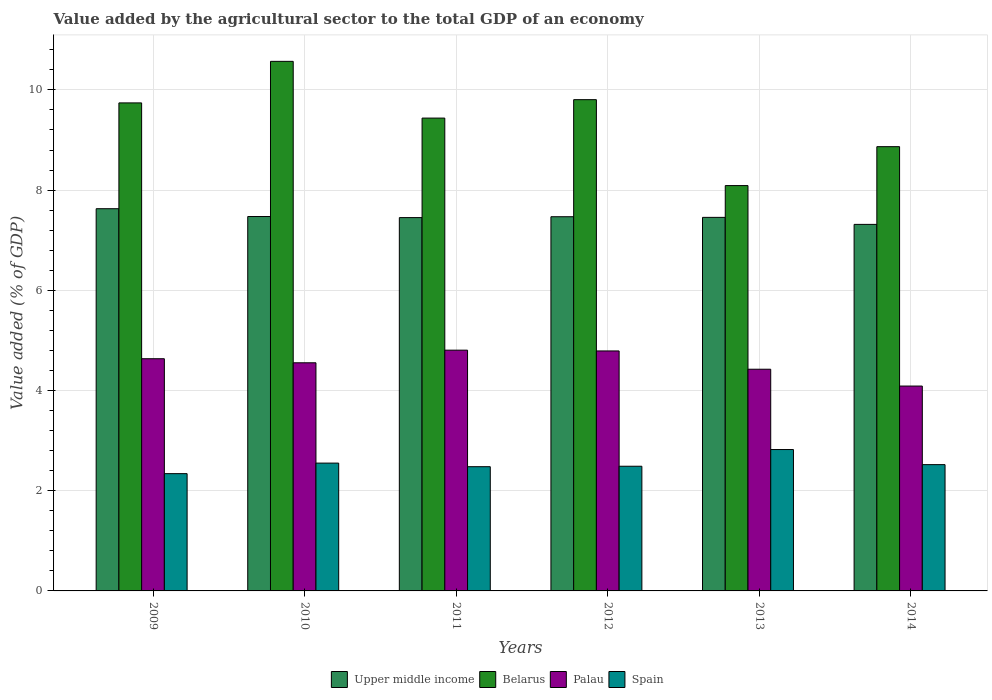How many different coloured bars are there?
Provide a succinct answer. 4. How many groups of bars are there?
Offer a terse response. 6. Are the number of bars per tick equal to the number of legend labels?
Provide a succinct answer. Yes. How many bars are there on the 2nd tick from the right?
Give a very brief answer. 4. What is the label of the 1st group of bars from the left?
Your response must be concise. 2009. In how many cases, is the number of bars for a given year not equal to the number of legend labels?
Provide a succinct answer. 0. What is the value added by the agricultural sector to the total GDP in Palau in 2014?
Offer a very short reply. 4.09. Across all years, what is the maximum value added by the agricultural sector to the total GDP in Spain?
Keep it short and to the point. 2.82. Across all years, what is the minimum value added by the agricultural sector to the total GDP in Upper middle income?
Give a very brief answer. 7.32. What is the total value added by the agricultural sector to the total GDP in Belarus in the graph?
Your response must be concise. 56.51. What is the difference between the value added by the agricultural sector to the total GDP in Spain in 2013 and that in 2014?
Offer a terse response. 0.3. What is the difference between the value added by the agricultural sector to the total GDP in Belarus in 2014 and the value added by the agricultural sector to the total GDP in Palau in 2009?
Your answer should be compact. 4.23. What is the average value added by the agricultural sector to the total GDP in Upper middle income per year?
Your answer should be compact. 7.47. In the year 2012, what is the difference between the value added by the agricultural sector to the total GDP in Spain and value added by the agricultural sector to the total GDP in Palau?
Offer a terse response. -2.3. In how many years, is the value added by the agricultural sector to the total GDP in Upper middle income greater than 8.8 %?
Provide a short and direct response. 0. What is the ratio of the value added by the agricultural sector to the total GDP in Palau in 2010 to that in 2011?
Offer a terse response. 0.95. Is the value added by the agricultural sector to the total GDP in Palau in 2010 less than that in 2014?
Offer a very short reply. No. What is the difference between the highest and the second highest value added by the agricultural sector to the total GDP in Upper middle income?
Keep it short and to the point. 0.16. What is the difference between the highest and the lowest value added by the agricultural sector to the total GDP in Palau?
Your answer should be compact. 0.72. Is it the case that in every year, the sum of the value added by the agricultural sector to the total GDP in Upper middle income and value added by the agricultural sector to the total GDP in Belarus is greater than the sum of value added by the agricultural sector to the total GDP in Palau and value added by the agricultural sector to the total GDP in Spain?
Your response must be concise. Yes. What does the 1st bar from the left in 2010 represents?
Your answer should be very brief. Upper middle income. What does the 4th bar from the right in 2013 represents?
Provide a succinct answer. Upper middle income. How many bars are there?
Keep it short and to the point. 24. Are all the bars in the graph horizontal?
Offer a terse response. No. How many years are there in the graph?
Offer a terse response. 6. What is the difference between two consecutive major ticks on the Y-axis?
Your answer should be very brief. 2. Does the graph contain any zero values?
Your answer should be compact. No. Does the graph contain grids?
Your response must be concise. Yes. How many legend labels are there?
Offer a very short reply. 4. How are the legend labels stacked?
Offer a terse response. Horizontal. What is the title of the graph?
Give a very brief answer. Value added by the agricultural sector to the total GDP of an economy. What is the label or title of the X-axis?
Your answer should be very brief. Years. What is the label or title of the Y-axis?
Offer a very short reply. Value added (% of GDP). What is the Value added (% of GDP) in Upper middle income in 2009?
Your response must be concise. 7.63. What is the Value added (% of GDP) of Belarus in 2009?
Ensure brevity in your answer.  9.74. What is the Value added (% of GDP) of Palau in 2009?
Provide a succinct answer. 4.63. What is the Value added (% of GDP) in Spain in 2009?
Your response must be concise. 2.34. What is the Value added (% of GDP) of Upper middle income in 2010?
Your answer should be compact. 7.47. What is the Value added (% of GDP) in Belarus in 2010?
Your response must be concise. 10.57. What is the Value added (% of GDP) in Palau in 2010?
Make the answer very short. 4.55. What is the Value added (% of GDP) in Spain in 2010?
Offer a very short reply. 2.55. What is the Value added (% of GDP) in Upper middle income in 2011?
Your answer should be compact. 7.45. What is the Value added (% of GDP) in Belarus in 2011?
Offer a very short reply. 9.44. What is the Value added (% of GDP) of Palau in 2011?
Offer a very short reply. 4.81. What is the Value added (% of GDP) in Spain in 2011?
Ensure brevity in your answer.  2.48. What is the Value added (% of GDP) in Upper middle income in 2012?
Offer a terse response. 7.47. What is the Value added (% of GDP) in Belarus in 2012?
Offer a very short reply. 9.8. What is the Value added (% of GDP) in Palau in 2012?
Your answer should be compact. 4.79. What is the Value added (% of GDP) in Spain in 2012?
Your answer should be very brief. 2.49. What is the Value added (% of GDP) in Upper middle income in 2013?
Your answer should be very brief. 7.46. What is the Value added (% of GDP) of Belarus in 2013?
Ensure brevity in your answer.  8.09. What is the Value added (% of GDP) of Palau in 2013?
Make the answer very short. 4.42. What is the Value added (% of GDP) of Spain in 2013?
Your answer should be compact. 2.82. What is the Value added (% of GDP) of Upper middle income in 2014?
Keep it short and to the point. 7.32. What is the Value added (% of GDP) in Belarus in 2014?
Give a very brief answer. 8.87. What is the Value added (% of GDP) of Palau in 2014?
Ensure brevity in your answer.  4.09. What is the Value added (% of GDP) of Spain in 2014?
Your response must be concise. 2.52. Across all years, what is the maximum Value added (% of GDP) of Upper middle income?
Give a very brief answer. 7.63. Across all years, what is the maximum Value added (% of GDP) in Belarus?
Your response must be concise. 10.57. Across all years, what is the maximum Value added (% of GDP) in Palau?
Your response must be concise. 4.81. Across all years, what is the maximum Value added (% of GDP) of Spain?
Your answer should be very brief. 2.82. Across all years, what is the minimum Value added (% of GDP) in Upper middle income?
Provide a short and direct response. 7.32. Across all years, what is the minimum Value added (% of GDP) in Belarus?
Provide a short and direct response. 8.09. Across all years, what is the minimum Value added (% of GDP) of Palau?
Offer a terse response. 4.09. Across all years, what is the minimum Value added (% of GDP) of Spain?
Offer a terse response. 2.34. What is the total Value added (% of GDP) in Upper middle income in the graph?
Offer a very short reply. 44.79. What is the total Value added (% of GDP) of Belarus in the graph?
Provide a succinct answer. 56.51. What is the total Value added (% of GDP) of Palau in the graph?
Your response must be concise. 27.3. What is the total Value added (% of GDP) of Spain in the graph?
Provide a succinct answer. 15.2. What is the difference between the Value added (% of GDP) in Upper middle income in 2009 and that in 2010?
Keep it short and to the point. 0.16. What is the difference between the Value added (% of GDP) of Belarus in 2009 and that in 2010?
Offer a terse response. -0.83. What is the difference between the Value added (% of GDP) of Palau in 2009 and that in 2010?
Your response must be concise. 0.08. What is the difference between the Value added (% of GDP) of Spain in 2009 and that in 2010?
Provide a short and direct response. -0.21. What is the difference between the Value added (% of GDP) of Upper middle income in 2009 and that in 2011?
Give a very brief answer. 0.18. What is the difference between the Value added (% of GDP) in Belarus in 2009 and that in 2011?
Your answer should be very brief. 0.3. What is the difference between the Value added (% of GDP) of Palau in 2009 and that in 2011?
Your answer should be very brief. -0.17. What is the difference between the Value added (% of GDP) in Spain in 2009 and that in 2011?
Provide a succinct answer. -0.14. What is the difference between the Value added (% of GDP) in Upper middle income in 2009 and that in 2012?
Provide a short and direct response. 0.16. What is the difference between the Value added (% of GDP) of Belarus in 2009 and that in 2012?
Ensure brevity in your answer.  -0.06. What is the difference between the Value added (% of GDP) of Palau in 2009 and that in 2012?
Make the answer very short. -0.16. What is the difference between the Value added (% of GDP) of Spain in 2009 and that in 2012?
Make the answer very short. -0.15. What is the difference between the Value added (% of GDP) in Upper middle income in 2009 and that in 2013?
Offer a very short reply. 0.17. What is the difference between the Value added (% of GDP) in Belarus in 2009 and that in 2013?
Your answer should be compact. 1.65. What is the difference between the Value added (% of GDP) in Palau in 2009 and that in 2013?
Ensure brevity in your answer.  0.21. What is the difference between the Value added (% of GDP) of Spain in 2009 and that in 2013?
Ensure brevity in your answer.  -0.48. What is the difference between the Value added (% of GDP) in Upper middle income in 2009 and that in 2014?
Ensure brevity in your answer.  0.31. What is the difference between the Value added (% of GDP) in Belarus in 2009 and that in 2014?
Keep it short and to the point. 0.87. What is the difference between the Value added (% of GDP) in Palau in 2009 and that in 2014?
Give a very brief answer. 0.55. What is the difference between the Value added (% of GDP) of Spain in 2009 and that in 2014?
Your answer should be very brief. -0.18. What is the difference between the Value added (% of GDP) in Upper middle income in 2010 and that in 2011?
Your answer should be very brief. 0.02. What is the difference between the Value added (% of GDP) in Belarus in 2010 and that in 2011?
Keep it short and to the point. 1.13. What is the difference between the Value added (% of GDP) of Palau in 2010 and that in 2011?
Make the answer very short. -0.25. What is the difference between the Value added (% of GDP) in Spain in 2010 and that in 2011?
Keep it short and to the point. 0.07. What is the difference between the Value added (% of GDP) in Upper middle income in 2010 and that in 2012?
Make the answer very short. 0. What is the difference between the Value added (% of GDP) in Belarus in 2010 and that in 2012?
Ensure brevity in your answer.  0.76. What is the difference between the Value added (% of GDP) of Palau in 2010 and that in 2012?
Your answer should be compact. -0.24. What is the difference between the Value added (% of GDP) of Spain in 2010 and that in 2012?
Offer a terse response. 0.06. What is the difference between the Value added (% of GDP) of Upper middle income in 2010 and that in 2013?
Your response must be concise. 0.02. What is the difference between the Value added (% of GDP) of Belarus in 2010 and that in 2013?
Your answer should be compact. 2.48. What is the difference between the Value added (% of GDP) in Palau in 2010 and that in 2013?
Make the answer very short. 0.13. What is the difference between the Value added (% of GDP) in Spain in 2010 and that in 2013?
Offer a terse response. -0.27. What is the difference between the Value added (% of GDP) of Upper middle income in 2010 and that in 2014?
Your answer should be compact. 0.16. What is the difference between the Value added (% of GDP) in Belarus in 2010 and that in 2014?
Provide a short and direct response. 1.7. What is the difference between the Value added (% of GDP) of Palau in 2010 and that in 2014?
Your answer should be very brief. 0.46. What is the difference between the Value added (% of GDP) in Spain in 2010 and that in 2014?
Keep it short and to the point. 0.03. What is the difference between the Value added (% of GDP) of Upper middle income in 2011 and that in 2012?
Ensure brevity in your answer.  -0.02. What is the difference between the Value added (% of GDP) in Belarus in 2011 and that in 2012?
Offer a terse response. -0.37. What is the difference between the Value added (% of GDP) of Palau in 2011 and that in 2012?
Your response must be concise. 0.02. What is the difference between the Value added (% of GDP) in Spain in 2011 and that in 2012?
Ensure brevity in your answer.  -0.01. What is the difference between the Value added (% of GDP) in Upper middle income in 2011 and that in 2013?
Your answer should be compact. -0. What is the difference between the Value added (% of GDP) of Belarus in 2011 and that in 2013?
Ensure brevity in your answer.  1.35. What is the difference between the Value added (% of GDP) in Palau in 2011 and that in 2013?
Make the answer very short. 0.38. What is the difference between the Value added (% of GDP) of Spain in 2011 and that in 2013?
Make the answer very short. -0.34. What is the difference between the Value added (% of GDP) of Upper middle income in 2011 and that in 2014?
Offer a very short reply. 0.14. What is the difference between the Value added (% of GDP) of Belarus in 2011 and that in 2014?
Your answer should be compact. 0.57. What is the difference between the Value added (% of GDP) in Palau in 2011 and that in 2014?
Provide a succinct answer. 0.72. What is the difference between the Value added (% of GDP) in Spain in 2011 and that in 2014?
Provide a short and direct response. -0.04. What is the difference between the Value added (% of GDP) in Upper middle income in 2012 and that in 2013?
Provide a succinct answer. 0.01. What is the difference between the Value added (% of GDP) in Belarus in 2012 and that in 2013?
Your answer should be compact. 1.72. What is the difference between the Value added (% of GDP) in Palau in 2012 and that in 2013?
Provide a succinct answer. 0.36. What is the difference between the Value added (% of GDP) in Upper middle income in 2012 and that in 2014?
Your response must be concise. 0.15. What is the difference between the Value added (% of GDP) in Belarus in 2012 and that in 2014?
Ensure brevity in your answer.  0.94. What is the difference between the Value added (% of GDP) in Palau in 2012 and that in 2014?
Provide a succinct answer. 0.7. What is the difference between the Value added (% of GDP) of Spain in 2012 and that in 2014?
Keep it short and to the point. -0.03. What is the difference between the Value added (% of GDP) in Upper middle income in 2013 and that in 2014?
Your response must be concise. 0.14. What is the difference between the Value added (% of GDP) of Belarus in 2013 and that in 2014?
Your answer should be very brief. -0.78. What is the difference between the Value added (% of GDP) in Palau in 2013 and that in 2014?
Your answer should be very brief. 0.34. What is the difference between the Value added (% of GDP) of Spain in 2013 and that in 2014?
Ensure brevity in your answer.  0.3. What is the difference between the Value added (% of GDP) of Upper middle income in 2009 and the Value added (% of GDP) of Belarus in 2010?
Provide a succinct answer. -2.94. What is the difference between the Value added (% of GDP) of Upper middle income in 2009 and the Value added (% of GDP) of Palau in 2010?
Provide a succinct answer. 3.08. What is the difference between the Value added (% of GDP) of Upper middle income in 2009 and the Value added (% of GDP) of Spain in 2010?
Your answer should be very brief. 5.08. What is the difference between the Value added (% of GDP) in Belarus in 2009 and the Value added (% of GDP) in Palau in 2010?
Keep it short and to the point. 5.19. What is the difference between the Value added (% of GDP) of Belarus in 2009 and the Value added (% of GDP) of Spain in 2010?
Make the answer very short. 7.19. What is the difference between the Value added (% of GDP) in Palau in 2009 and the Value added (% of GDP) in Spain in 2010?
Offer a terse response. 2.08. What is the difference between the Value added (% of GDP) of Upper middle income in 2009 and the Value added (% of GDP) of Belarus in 2011?
Ensure brevity in your answer.  -1.81. What is the difference between the Value added (% of GDP) in Upper middle income in 2009 and the Value added (% of GDP) in Palau in 2011?
Your answer should be compact. 2.82. What is the difference between the Value added (% of GDP) in Upper middle income in 2009 and the Value added (% of GDP) in Spain in 2011?
Provide a short and direct response. 5.15. What is the difference between the Value added (% of GDP) of Belarus in 2009 and the Value added (% of GDP) of Palau in 2011?
Your response must be concise. 4.93. What is the difference between the Value added (% of GDP) of Belarus in 2009 and the Value added (% of GDP) of Spain in 2011?
Make the answer very short. 7.26. What is the difference between the Value added (% of GDP) of Palau in 2009 and the Value added (% of GDP) of Spain in 2011?
Make the answer very short. 2.15. What is the difference between the Value added (% of GDP) in Upper middle income in 2009 and the Value added (% of GDP) in Belarus in 2012?
Make the answer very short. -2.18. What is the difference between the Value added (% of GDP) in Upper middle income in 2009 and the Value added (% of GDP) in Palau in 2012?
Your response must be concise. 2.84. What is the difference between the Value added (% of GDP) of Upper middle income in 2009 and the Value added (% of GDP) of Spain in 2012?
Your answer should be compact. 5.14. What is the difference between the Value added (% of GDP) in Belarus in 2009 and the Value added (% of GDP) in Palau in 2012?
Offer a very short reply. 4.95. What is the difference between the Value added (% of GDP) in Belarus in 2009 and the Value added (% of GDP) in Spain in 2012?
Ensure brevity in your answer.  7.25. What is the difference between the Value added (% of GDP) of Palau in 2009 and the Value added (% of GDP) of Spain in 2012?
Your response must be concise. 2.15. What is the difference between the Value added (% of GDP) of Upper middle income in 2009 and the Value added (% of GDP) of Belarus in 2013?
Offer a very short reply. -0.46. What is the difference between the Value added (% of GDP) in Upper middle income in 2009 and the Value added (% of GDP) in Palau in 2013?
Your response must be concise. 3.2. What is the difference between the Value added (% of GDP) in Upper middle income in 2009 and the Value added (% of GDP) in Spain in 2013?
Provide a succinct answer. 4.81. What is the difference between the Value added (% of GDP) in Belarus in 2009 and the Value added (% of GDP) in Palau in 2013?
Keep it short and to the point. 5.32. What is the difference between the Value added (% of GDP) of Belarus in 2009 and the Value added (% of GDP) of Spain in 2013?
Your response must be concise. 6.92. What is the difference between the Value added (% of GDP) in Palau in 2009 and the Value added (% of GDP) in Spain in 2013?
Keep it short and to the point. 1.81. What is the difference between the Value added (% of GDP) of Upper middle income in 2009 and the Value added (% of GDP) of Belarus in 2014?
Make the answer very short. -1.24. What is the difference between the Value added (% of GDP) of Upper middle income in 2009 and the Value added (% of GDP) of Palau in 2014?
Your response must be concise. 3.54. What is the difference between the Value added (% of GDP) in Upper middle income in 2009 and the Value added (% of GDP) in Spain in 2014?
Ensure brevity in your answer.  5.11. What is the difference between the Value added (% of GDP) of Belarus in 2009 and the Value added (% of GDP) of Palau in 2014?
Offer a terse response. 5.65. What is the difference between the Value added (% of GDP) of Belarus in 2009 and the Value added (% of GDP) of Spain in 2014?
Your answer should be very brief. 7.22. What is the difference between the Value added (% of GDP) of Palau in 2009 and the Value added (% of GDP) of Spain in 2014?
Offer a terse response. 2.11. What is the difference between the Value added (% of GDP) of Upper middle income in 2010 and the Value added (% of GDP) of Belarus in 2011?
Give a very brief answer. -1.96. What is the difference between the Value added (% of GDP) in Upper middle income in 2010 and the Value added (% of GDP) in Palau in 2011?
Provide a succinct answer. 2.67. What is the difference between the Value added (% of GDP) in Upper middle income in 2010 and the Value added (% of GDP) in Spain in 2011?
Make the answer very short. 4.99. What is the difference between the Value added (% of GDP) in Belarus in 2010 and the Value added (% of GDP) in Palau in 2011?
Your response must be concise. 5.76. What is the difference between the Value added (% of GDP) in Belarus in 2010 and the Value added (% of GDP) in Spain in 2011?
Your answer should be very brief. 8.09. What is the difference between the Value added (% of GDP) in Palau in 2010 and the Value added (% of GDP) in Spain in 2011?
Offer a terse response. 2.07. What is the difference between the Value added (% of GDP) in Upper middle income in 2010 and the Value added (% of GDP) in Belarus in 2012?
Ensure brevity in your answer.  -2.33. What is the difference between the Value added (% of GDP) of Upper middle income in 2010 and the Value added (% of GDP) of Palau in 2012?
Your answer should be very brief. 2.68. What is the difference between the Value added (% of GDP) of Upper middle income in 2010 and the Value added (% of GDP) of Spain in 2012?
Offer a terse response. 4.98. What is the difference between the Value added (% of GDP) of Belarus in 2010 and the Value added (% of GDP) of Palau in 2012?
Your answer should be compact. 5.78. What is the difference between the Value added (% of GDP) in Belarus in 2010 and the Value added (% of GDP) in Spain in 2012?
Offer a terse response. 8.08. What is the difference between the Value added (% of GDP) of Palau in 2010 and the Value added (% of GDP) of Spain in 2012?
Offer a very short reply. 2.06. What is the difference between the Value added (% of GDP) of Upper middle income in 2010 and the Value added (% of GDP) of Belarus in 2013?
Offer a very short reply. -0.62. What is the difference between the Value added (% of GDP) of Upper middle income in 2010 and the Value added (% of GDP) of Palau in 2013?
Give a very brief answer. 3.05. What is the difference between the Value added (% of GDP) of Upper middle income in 2010 and the Value added (% of GDP) of Spain in 2013?
Offer a terse response. 4.65. What is the difference between the Value added (% of GDP) of Belarus in 2010 and the Value added (% of GDP) of Palau in 2013?
Provide a succinct answer. 6.14. What is the difference between the Value added (% of GDP) in Belarus in 2010 and the Value added (% of GDP) in Spain in 2013?
Keep it short and to the point. 7.75. What is the difference between the Value added (% of GDP) in Palau in 2010 and the Value added (% of GDP) in Spain in 2013?
Offer a terse response. 1.73. What is the difference between the Value added (% of GDP) in Upper middle income in 2010 and the Value added (% of GDP) in Belarus in 2014?
Your answer should be very brief. -1.39. What is the difference between the Value added (% of GDP) of Upper middle income in 2010 and the Value added (% of GDP) of Palau in 2014?
Provide a short and direct response. 3.38. What is the difference between the Value added (% of GDP) of Upper middle income in 2010 and the Value added (% of GDP) of Spain in 2014?
Your answer should be compact. 4.95. What is the difference between the Value added (% of GDP) in Belarus in 2010 and the Value added (% of GDP) in Palau in 2014?
Your answer should be very brief. 6.48. What is the difference between the Value added (% of GDP) of Belarus in 2010 and the Value added (% of GDP) of Spain in 2014?
Your response must be concise. 8.05. What is the difference between the Value added (% of GDP) in Palau in 2010 and the Value added (% of GDP) in Spain in 2014?
Offer a very short reply. 2.03. What is the difference between the Value added (% of GDP) in Upper middle income in 2011 and the Value added (% of GDP) in Belarus in 2012?
Make the answer very short. -2.35. What is the difference between the Value added (% of GDP) of Upper middle income in 2011 and the Value added (% of GDP) of Palau in 2012?
Offer a terse response. 2.66. What is the difference between the Value added (% of GDP) of Upper middle income in 2011 and the Value added (% of GDP) of Spain in 2012?
Provide a succinct answer. 4.96. What is the difference between the Value added (% of GDP) of Belarus in 2011 and the Value added (% of GDP) of Palau in 2012?
Give a very brief answer. 4.65. What is the difference between the Value added (% of GDP) of Belarus in 2011 and the Value added (% of GDP) of Spain in 2012?
Provide a short and direct response. 6.95. What is the difference between the Value added (% of GDP) of Palau in 2011 and the Value added (% of GDP) of Spain in 2012?
Offer a terse response. 2.32. What is the difference between the Value added (% of GDP) in Upper middle income in 2011 and the Value added (% of GDP) in Belarus in 2013?
Your response must be concise. -0.64. What is the difference between the Value added (% of GDP) of Upper middle income in 2011 and the Value added (% of GDP) of Palau in 2013?
Provide a short and direct response. 3.03. What is the difference between the Value added (% of GDP) of Upper middle income in 2011 and the Value added (% of GDP) of Spain in 2013?
Ensure brevity in your answer.  4.63. What is the difference between the Value added (% of GDP) of Belarus in 2011 and the Value added (% of GDP) of Palau in 2013?
Your response must be concise. 5.01. What is the difference between the Value added (% of GDP) of Belarus in 2011 and the Value added (% of GDP) of Spain in 2013?
Provide a succinct answer. 6.62. What is the difference between the Value added (% of GDP) of Palau in 2011 and the Value added (% of GDP) of Spain in 2013?
Ensure brevity in your answer.  1.98. What is the difference between the Value added (% of GDP) of Upper middle income in 2011 and the Value added (% of GDP) of Belarus in 2014?
Your response must be concise. -1.42. What is the difference between the Value added (% of GDP) in Upper middle income in 2011 and the Value added (% of GDP) in Palau in 2014?
Provide a short and direct response. 3.36. What is the difference between the Value added (% of GDP) of Upper middle income in 2011 and the Value added (% of GDP) of Spain in 2014?
Ensure brevity in your answer.  4.93. What is the difference between the Value added (% of GDP) in Belarus in 2011 and the Value added (% of GDP) in Palau in 2014?
Make the answer very short. 5.35. What is the difference between the Value added (% of GDP) in Belarus in 2011 and the Value added (% of GDP) in Spain in 2014?
Ensure brevity in your answer.  6.92. What is the difference between the Value added (% of GDP) of Palau in 2011 and the Value added (% of GDP) of Spain in 2014?
Ensure brevity in your answer.  2.28. What is the difference between the Value added (% of GDP) of Upper middle income in 2012 and the Value added (% of GDP) of Belarus in 2013?
Offer a terse response. -0.62. What is the difference between the Value added (% of GDP) of Upper middle income in 2012 and the Value added (% of GDP) of Palau in 2013?
Give a very brief answer. 3.04. What is the difference between the Value added (% of GDP) in Upper middle income in 2012 and the Value added (% of GDP) in Spain in 2013?
Provide a short and direct response. 4.65. What is the difference between the Value added (% of GDP) of Belarus in 2012 and the Value added (% of GDP) of Palau in 2013?
Provide a succinct answer. 5.38. What is the difference between the Value added (% of GDP) in Belarus in 2012 and the Value added (% of GDP) in Spain in 2013?
Provide a succinct answer. 6.98. What is the difference between the Value added (% of GDP) in Palau in 2012 and the Value added (% of GDP) in Spain in 2013?
Offer a very short reply. 1.97. What is the difference between the Value added (% of GDP) of Upper middle income in 2012 and the Value added (% of GDP) of Belarus in 2014?
Your answer should be compact. -1.4. What is the difference between the Value added (% of GDP) in Upper middle income in 2012 and the Value added (% of GDP) in Palau in 2014?
Give a very brief answer. 3.38. What is the difference between the Value added (% of GDP) in Upper middle income in 2012 and the Value added (% of GDP) in Spain in 2014?
Provide a succinct answer. 4.95. What is the difference between the Value added (% of GDP) of Belarus in 2012 and the Value added (% of GDP) of Palau in 2014?
Ensure brevity in your answer.  5.72. What is the difference between the Value added (% of GDP) of Belarus in 2012 and the Value added (% of GDP) of Spain in 2014?
Your answer should be compact. 7.28. What is the difference between the Value added (% of GDP) in Palau in 2012 and the Value added (% of GDP) in Spain in 2014?
Make the answer very short. 2.27. What is the difference between the Value added (% of GDP) in Upper middle income in 2013 and the Value added (% of GDP) in Belarus in 2014?
Your answer should be compact. -1.41. What is the difference between the Value added (% of GDP) of Upper middle income in 2013 and the Value added (% of GDP) of Palau in 2014?
Offer a terse response. 3.37. What is the difference between the Value added (% of GDP) of Upper middle income in 2013 and the Value added (% of GDP) of Spain in 2014?
Provide a short and direct response. 4.93. What is the difference between the Value added (% of GDP) of Belarus in 2013 and the Value added (% of GDP) of Palau in 2014?
Make the answer very short. 4. What is the difference between the Value added (% of GDP) in Belarus in 2013 and the Value added (% of GDP) in Spain in 2014?
Ensure brevity in your answer.  5.57. What is the difference between the Value added (% of GDP) of Palau in 2013 and the Value added (% of GDP) of Spain in 2014?
Provide a succinct answer. 1.9. What is the average Value added (% of GDP) in Upper middle income per year?
Provide a short and direct response. 7.47. What is the average Value added (% of GDP) in Belarus per year?
Offer a terse response. 9.42. What is the average Value added (% of GDP) of Palau per year?
Make the answer very short. 4.55. What is the average Value added (% of GDP) of Spain per year?
Provide a succinct answer. 2.53. In the year 2009, what is the difference between the Value added (% of GDP) of Upper middle income and Value added (% of GDP) of Belarus?
Your response must be concise. -2.11. In the year 2009, what is the difference between the Value added (% of GDP) in Upper middle income and Value added (% of GDP) in Palau?
Keep it short and to the point. 2.99. In the year 2009, what is the difference between the Value added (% of GDP) in Upper middle income and Value added (% of GDP) in Spain?
Provide a short and direct response. 5.29. In the year 2009, what is the difference between the Value added (% of GDP) in Belarus and Value added (% of GDP) in Palau?
Your answer should be compact. 5.11. In the year 2009, what is the difference between the Value added (% of GDP) of Belarus and Value added (% of GDP) of Spain?
Provide a short and direct response. 7.4. In the year 2009, what is the difference between the Value added (% of GDP) in Palau and Value added (% of GDP) in Spain?
Make the answer very short. 2.29. In the year 2010, what is the difference between the Value added (% of GDP) in Upper middle income and Value added (% of GDP) in Belarus?
Ensure brevity in your answer.  -3.1. In the year 2010, what is the difference between the Value added (% of GDP) of Upper middle income and Value added (% of GDP) of Palau?
Provide a succinct answer. 2.92. In the year 2010, what is the difference between the Value added (% of GDP) in Upper middle income and Value added (% of GDP) in Spain?
Offer a terse response. 4.92. In the year 2010, what is the difference between the Value added (% of GDP) of Belarus and Value added (% of GDP) of Palau?
Offer a terse response. 6.02. In the year 2010, what is the difference between the Value added (% of GDP) in Belarus and Value added (% of GDP) in Spain?
Provide a short and direct response. 8.02. In the year 2010, what is the difference between the Value added (% of GDP) of Palau and Value added (% of GDP) of Spain?
Ensure brevity in your answer.  2. In the year 2011, what is the difference between the Value added (% of GDP) in Upper middle income and Value added (% of GDP) in Belarus?
Your answer should be very brief. -1.99. In the year 2011, what is the difference between the Value added (% of GDP) of Upper middle income and Value added (% of GDP) of Palau?
Make the answer very short. 2.65. In the year 2011, what is the difference between the Value added (% of GDP) in Upper middle income and Value added (% of GDP) in Spain?
Provide a short and direct response. 4.97. In the year 2011, what is the difference between the Value added (% of GDP) of Belarus and Value added (% of GDP) of Palau?
Offer a very short reply. 4.63. In the year 2011, what is the difference between the Value added (% of GDP) in Belarus and Value added (% of GDP) in Spain?
Offer a very short reply. 6.96. In the year 2011, what is the difference between the Value added (% of GDP) in Palau and Value added (% of GDP) in Spain?
Make the answer very short. 2.33. In the year 2012, what is the difference between the Value added (% of GDP) in Upper middle income and Value added (% of GDP) in Belarus?
Offer a very short reply. -2.34. In the year 2012, what is the difference between the Value added (% of GDP) in Upper middle income and Value added (% of GDP) in Palau?
Provide a short and direct response. 2.68. In the year 2012, what is the difference between the Value added (% of GDP) in Upper middle income and Value added (% of GDP) in Spain?
Provide a short and direct response. 4.98. In the year 2012, what is the difference between the Value added (% of GDP) of Belarus and Value added (% of GDP) of Palau?
Offer a terse response. 5.02. In the year 2012, what is the difference between the Value added (% of GDP) of Belarus and Value added (% of GDP) of Spain?
Make the answer very short. 7.32. In the year 2012, what is the difference between the Value added (% of GDP) in Palau and Value added (% of GDP) in Spain?
Provide a succinct answer. 2.3. In the year 2013, what is the difference between the Value added (% of GDP) of Upper middle income and Value added (% of GDP) of Belarus?
Make the answer very short. -0.63. In the year 2013, what is the difference between the Value added (% of GDP) of Upper middle income and Value added (% of GDP) of Palau?
Offer a very short reply. 3.03. In the year 2013, what is the difference between the Value added (% of GDP) of Upper middle income and Value added (% of GDP) of Spain?
Your answer should be very brief. 4.63. In the year 2013, what is the difference between the Value added (% of GDP) in Belarus and Value added (% of GDP) in Palau?
Make the answer very short. 3.67. In the year 2013, what is the difference between the Value added (% of GDP) of Belarus and Value added (% of GDP) of Spain?
Provide a succinct answer. 5.27. In the year 2013, what is the difference between the Value added (% of GDP) in Palau and Value added (% of GDP) in Spain?
Provide a succinct answer. 1.6. In the year 2014, what is the difference between the Value added (% of GDP) in Upper middle income and Value added (% of GDP) in Belarus?
Give a very brief answer. -1.55. In the year 2014, what is the difference between the Value added (% of GDP) in Upper middle income and Value added (% of GDP) in Palau?
Keep it short and to the point. 3.23. In the year 2014, what is the difference between the Value added (% of GDP) of Upper middle income and Value added (% of GDP) of Spain?
Provide a succinct answer. 4.79. In the year 2014, what is the difference between the Value added (% of GDP) of Belarus and Value added (% of GDP) of Palau?
Provide a succinct answer. 4.78. In the year 2014, what is the difference between the Value added (% of GDP) of Belarus and Value added (% of GDP) of Spain?
Keep it short and to the point. 6.35. In the year 2014, what is the difference between the Value added (% of GDP) in Palau and Value added (% of GDP) in Spain?
Your answer should be very brief. 1.57. What is the ratio of the Value added (% of GDP) in Upper middle income in 2009 to that in 2010?
Provide a succinct answer. 1.02. What is the ratio of the Value added (% of GDP) of Belarus in 2009 to that in 2010?
Your answer should be very brief. 0.92. What is the ratio of the Value added (% of GDP) in Palau in 2009 to that in 2010?
Provide a short and direct response. 1.02. What is the ratio of the Value added (% of GDP) in Spain in 2009 to that in 2010?
Provide a short and direct response. 0.92. What is the ratio of the Value added (% of GDP) of Upper middle income in 2009 to that in 2011?
Offer a terse response. 1.02. What is the ratio of the Value added (% of GDP) of Belarus in 2009 to that in 2011?
Your answer should be very brief. 1.03. What is the ratio of the Value added (% of GDP) of Palau in 2009 to that in 2011?
Give a very brief answer. 0.96. What is the ratio of the Value added (% of GDP) in Spain in 2009 to that in 2011?
Your answer should be compact. 0.94. What is the ratio of the Value added (% of GDP) of Upper middle income in 2009 to that in 2012?
Your answer should be compact. 1.02. What is the ratio of the Value added (% of GDP) in Palau in 2009 to that in 2012?
Offer a terse response. 0.97. What is the ratio of the Value added (% of GDP) in Spain in 2009 to that in 2012?
Make the answer very short. 0.94. What is the ratio of the Value added (% of GDP) in Upper middle income in 2009 to that in 2013?
Offer a terse response. 1.02. What is the ratio of the Value added (% of GDP) of Belarus in 2009 to that in 2013?
Ensure brevity in your answer.  1.2. What is the ratio of the Value added (% of GDP) in Palau in 2009 to that in 2013?
Your answer should be very brief. 1.05. What is the ratio of the Value added (% of GDP) in Spain in 2009 to that in 2013?
Give a very brief answer. 0.83. What is the ratio of the Value added (% of GDP) of Upper middle income in 2009 to that in 2014?
Your response must be concise. 1.04. What is the ratio of the Value added (% of GDP) in Belarus in 2009 to that in 2014?
Your response must be concise. 1.1. What is the ratio of the Value added (% of GDP) of Palau in 2009 to that in 2014?
Offer a very short reply. 1.13. What is the ratio of the Value added (% of GDP) in Belarus in 2010 to that in 2011?
Provide a short and direct response. 1.12. What is the ratio of the Value added (% of GDP) of Palau in 2010 to that in 2011?
Give a very brief answer. 0.95. What is the ratio of the Value added (% of GDP) in Spain in 2010 to that in 2011?
Your response must be concise. 1.03. What is the ratio of the Value added (% of GDP) in Upper middle income in 2010 to that in 2012?
Your answer should be very brief. 1. What is the ratio of the Value added (% of GDP) in Belarus in 2010 to that in 2012?
Your response must be concise. 1.08. What is the ratio of the Value added (% of GDP) in Palau in 2010 to that in 2012?
Your response must be concise. 0.95. What is the ratio of the Value added (% of GDP) of Spain in 2010 to that in 2012?
Provide a succinct answer. 1.03. What is the ratio of the Value added (% of GDP) of Belarus in 2010 to that in 2013?
Offer a terse response. 1.31. What is the ratio of the Value added (% of GDP) in Palau in 2010 to that in 2013?
Give a very brief answer. 1.03. What is the ratio of the Value added (% of GDP) of Spain in 2010 to that in 2013?
Give a very brief answer. 0.9. What is the ratio of the Value added (% of GDP) of Upper middle income in 2010 to that in 2014?
Your answer should be very brief. 1.02. What is the ratio of the Value added (% of GDP) of Belarus in 2010 to that in 2014?
Make the answer very short. 1.19. What is the ratio of the Value added (% of GDP) in Palau in 2010 to that in 2014?
Offer a terse response. 1.11. What is the ratio of the Value added (% of GDP) in Spain in 2010 to that in 2014?
Your answer should be compact. 1.01. What is the ratio of the Value added (% of GDP) in Upper middle income in 2011 to that in 2012?
Offer a terse response. 1. What is the ratio of the Value added (% of GDP) of Belarus in 2011 to that in 2012?
Your answer should be very brief. 0.96. What is the ratio of the Value added (% of GDP) in Belarus in 2011 to that in 2013?
Provide a short and direct response. 1.17. What is the ratio of the Value added (% of GDP) in Palau in 2011 to that in 2013?
Offer a terse response. 1.09. What is the ratio of the Value added (% of GDP) in Spain in 2011 to that in 2013?
Provide a succinct answer. 0.88. What is the ratio of the Value added (% of GDP) in Upper middle income in 2011 to that in 2014?
Your answer should be compact. 1.02. What is the ratio of the Value added (% of GDP) in Belarus in 2011 to that in 2014?
Provide a succinct answer. 1.06. What is the ratio of the Value added (% of GDP) in Palau in 2011 to that in 2014?
Your response must be concise. 1.18. What is the ratio of the Value added (% of GDP) of Spain in 2011 to that in 2014?
Make the answer very short. 0.98. What is the ratio of the Value added (% of GDP) in Upper middle income in 2012 to that in 2013?
Offer a very short reply. 1. What is the ratio of the Value added (% of GDP) in Belarus in 2012 to that in 2013?
Provide a succinct answer. 1.21. What is the ratio of the Value added (% of GDP) in Palau in 2012 to that in 2013?
Offer a very short reply. 1.08. What is the ratio of the Value added (% of GDP) of Spain in 2012 to that in 2013?
Make the answer very short. 0.88. What is the ratio of the Value added (% of GDP) of Upper middle income in 2012 to that in 2014?
Offer a very short reply. 1.02. What is the ratio of the Value added (% of GDP) of Belarus in 2012 to that in 2014?
Make the answer very short. 1.11. What is the ratio of the Value added (% of GDP) in Palau in 2012 to that in 2014?
Give a very brief answer. 1.17. What is the ratio of the Value added (% of GDP) of Spain in 2012 to that in 2014?
Your answer should be very brief. 0.99. What is the ratio of the Value added (% of GDP) in Upper middle income in 2013 to that in 2014?
Your answer should be very brief. 1.02. What is the ratio of the Value added (% of GDP) of Belarus in 2013 to that in 2014?
Offer a very short reply. 0.91. What is the ratio of the Value added (% of GDP) of Palau in 2013 to that in 2014?
Give a very brief answer. 1.08. What is the ratio of the Value added (% of GDP) in Spain in 2013 to that in 2014?
Make the answer very short. 1.12. What is the difference between the highest and the second highest Value added (% of GDP) of Upper middle income?
Provide a short and direct response. 0.16. What is the difference between the highest and the second highest Value added (% of GDP) in Belarus?
Make the answer very short. 0.76. What is the difference between the highest and the second highest Value added (% of GDP) in Palau?
Give a very brief answer. 0.02. What is the difference between the highest and the second highest Value added (% of GDP) of Spain?
Ensure brevity in your answer.  0.27. What is the difference between the highest and the lowest Value added (% of GDP) in Upper middle income?
Provide a short and direct response. 0.31. What is the difference between the highest and the lowest Value added (% of GDP) of Belarus?
Give a very brief answer. 2.48. What is the difference between the highest and the lowest Value added (% of GDP) of Palau?
Offer a very short reply. 0.72. What is the difference between the highest and the lowest Value added (% of GDP) in Spain?
Offer a very short reply. 0.48. 